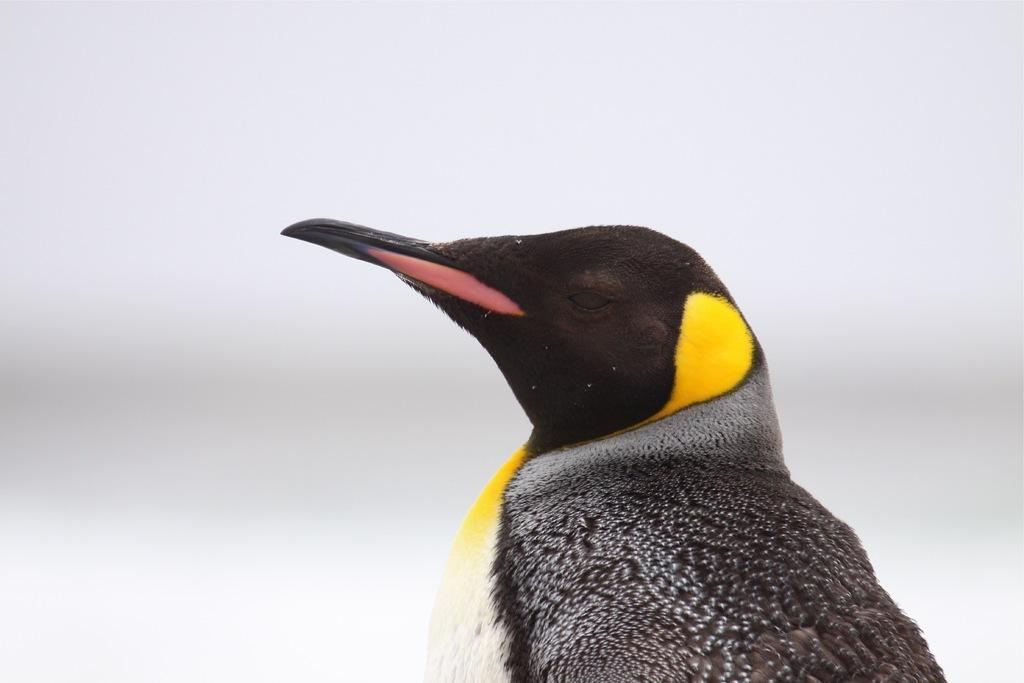What color is the background of the image? The background of the image is white. What type of animal can be seen in the image? There is a bird in the image. What type of payment does the bird receive for its performance in the image? There is no indication in the image that the bird is performing or receiving any payment. 